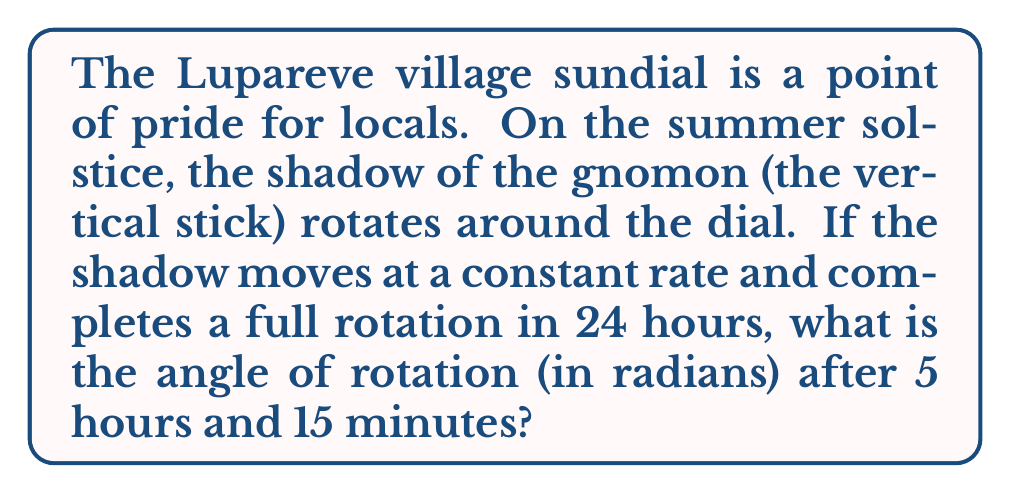Provide a solution to this math problem. To solve this problem, we need to follow these steps:

1) First, let's establish the relationship between time and angle:
   - A full rotation (360° or $2\pi$ radians) occurs in 24 hours

2) We can set up a proportion:
   $$\frac{2\pi\text{ radians}}{24\text{ hours}} = \frac{x\text{ radians}}{5.25\text{ hours}}$$

   Where 5.25 hours is 5 hours and 15 minutes in decimal form.

3) Cross multiply:
   $$24x = 2\pi \cdot 5.25$$

4) Solve for x:
   $$x = \frac{2\pi \cdot 5.25}{24}$$

5) Simplify:
   $$x = \frac{2\pi \cdot 21}{96} = \frac{7\pi}{16}$$

Therefore, after 5 hours and 15 minutes, the shadow of the Lupareve village sundial will have rotated by $\frac{7\pi}{16}$ radians.
Answer: $\frac{7\pi}{16}$ radians 